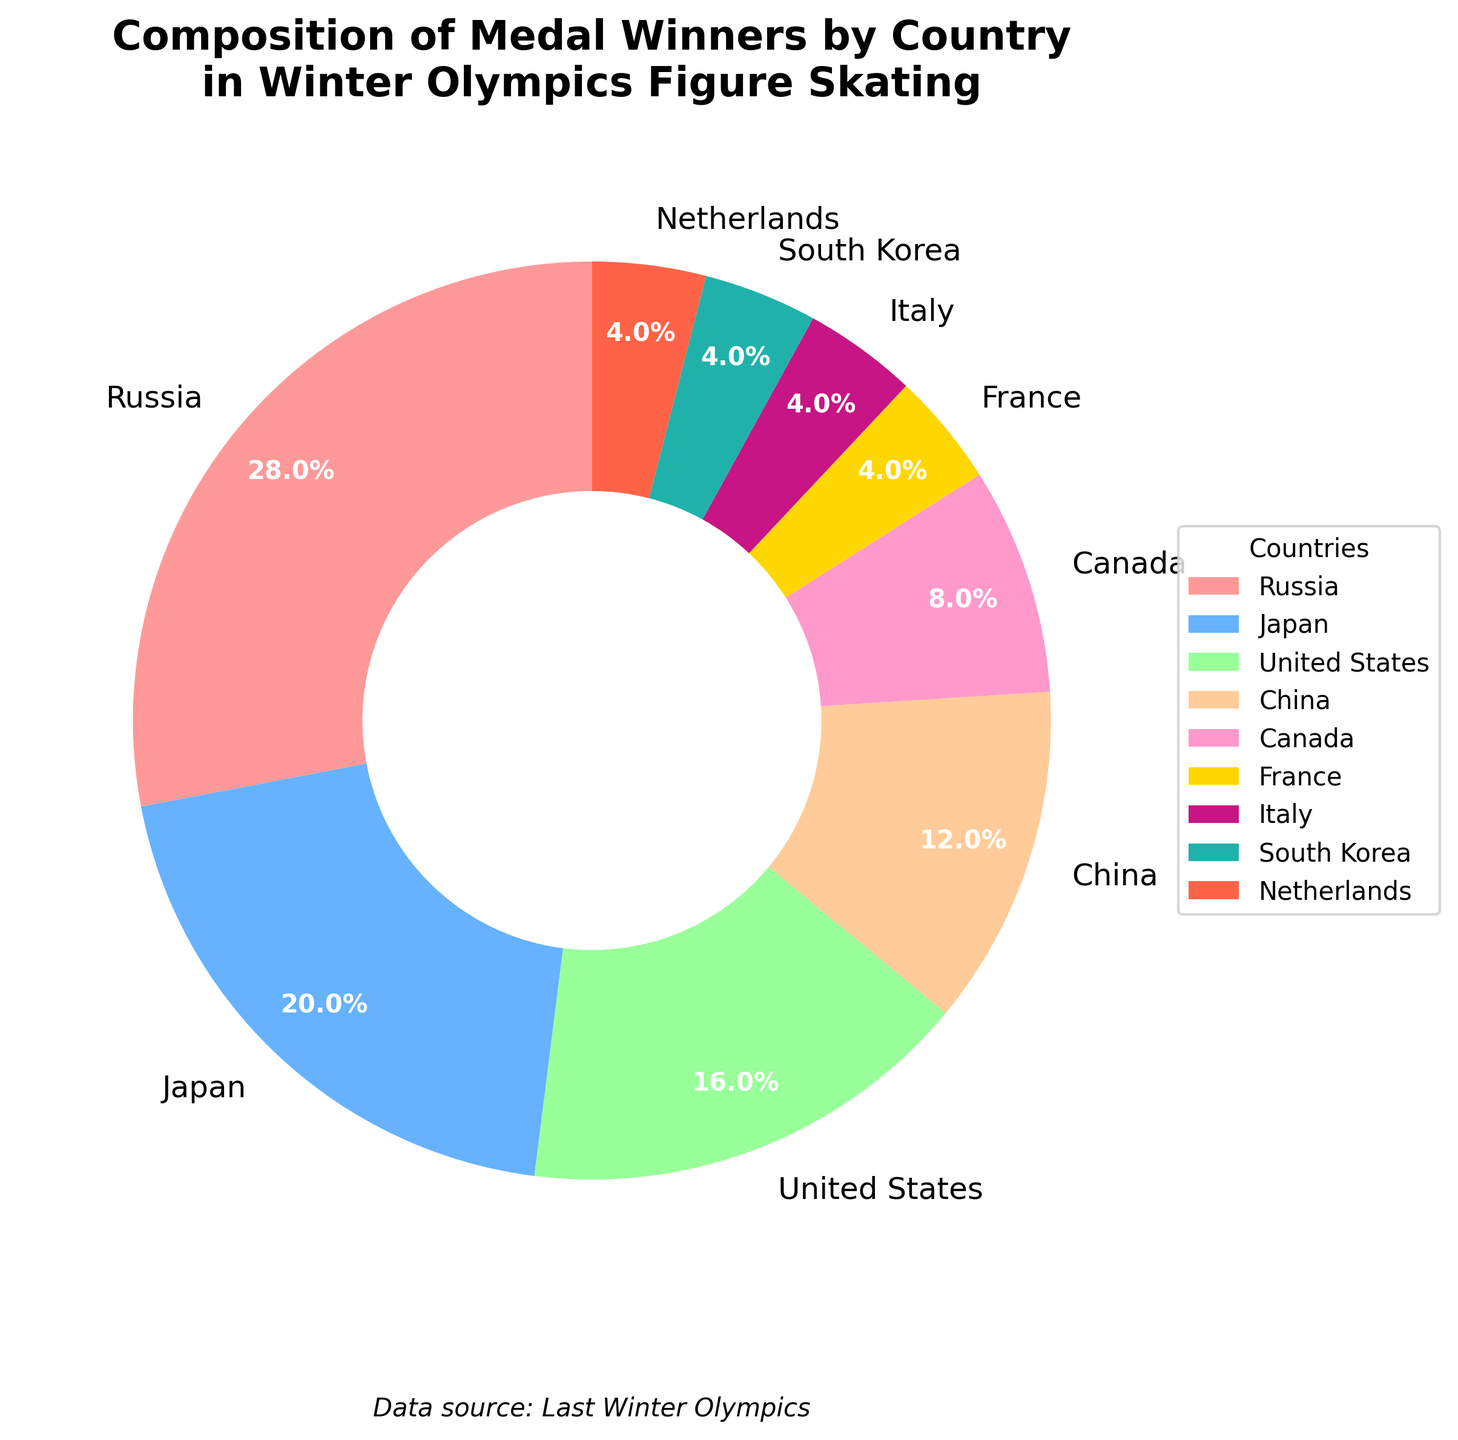what percentage of medals did Russia win? The pie chart shows that Russia has the largest section, with 7 medals out of a total of 25 medals. To find the percentage, divide 7 by 25 and multiply by 100. (7/25) * 100 = 28%
Answer: 28% which country won the least number of medals? Several countries have the smallest slices with only 1 medal each. These countries are France, Italy, South Korea, and the Netherlands.
Answer: France, Italy, South Korea, Netherlands how many more medals did Russia win compared to China? Russia has 7 medals, and China has 3 medals. Subtracting China's total from Russia's total gives the difference: 7 - 3 = 4.
Answer: 4 how many countries won exactly one medal? The pie chart shows four countries with the smallest slices, each labeled with "1". These countries are France, Italy, South Korea, and the Netherlands.
Answer: 4 is Japan's share of medals greater than Canada's? Japan's slice is labeled with "5" medals, while Canada's slice is labeled with "2" medals. 5 is greater than 2, so Japan's share is greater.
Answer: Yes what is the sum of medals won by the United States and Canada? The United States has 4 medals and Canada has 2. Adding these together gives: 4 + 2 = 6.
Answer: 6 which country’s slice is colored in green? According to the custom color palette, the shade of green is typically associated with the third slice. Referring to the pie chart, the green section corresponds to the United States.
Answer: United States what is the difference between the total medals won by China and South Korea? China has 3 medals while South Korea has 1 medal. Subtracting South Korea's total from China's total gives: 3 - 1 = 2.
Answer: 2 if medals were split evenly among all countries, how many would each country receive? To find the even split, divide the total number of medals by the number of countries involved. There are 25 medals and 9 countries: 25 / 9 ≈ 2.78.
Answer: Approximately 2.78 which countries' shares combined make up almost one-third of the total medals? One-third of the total medals (25) equals 8.33. By combining China's 3 medals and Japan’s 5 medals, we get: 3 + 5 = 8, which is very close to a third.
Answer: China and Japan 